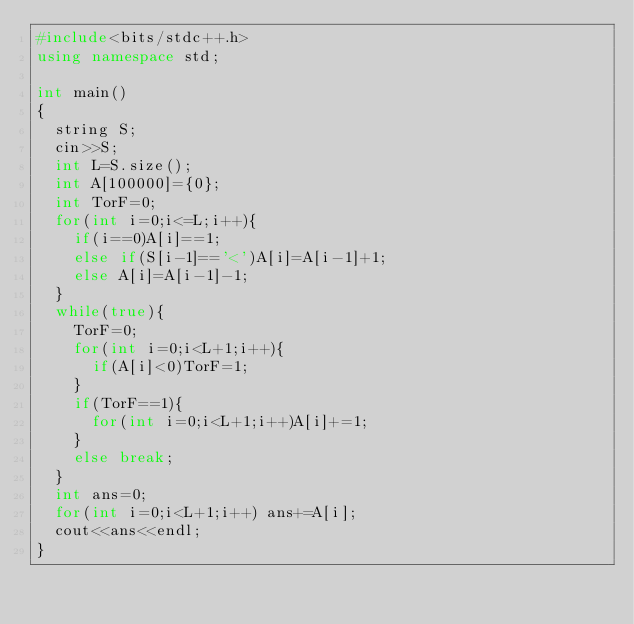Convert code to text. <code><loc_0><loc_0><loc_500><loc_500><_C++_>#include<bits/stdc++.h>
using namespace std;

int main()
{
  string S;
  cin>>S;
  int L=S.size();
  int A[100000]={0};
  int TorF=0;
  for(int i=0;i<=L;i++){
    if(i==0)A[i]==1;
    else if(S[i-1]=='<')A[i]=A[i-1]+1;
    else A[i]=A[i-1]-1;
  }
  while(true){
    TorF=0;
    for(int i=0;i<L+1;i++){
      if(A[i]<0)TorF=1;
    }
    if(TorF==1){
      for(int i=0;i<L+1;i++)A[i]+=1;
    }
    else break;
  }
  int ans=0;
  for(int i=0;i<L+1;i++) ans+=A[i];
  cout<<ans<<endl;
}</code> 